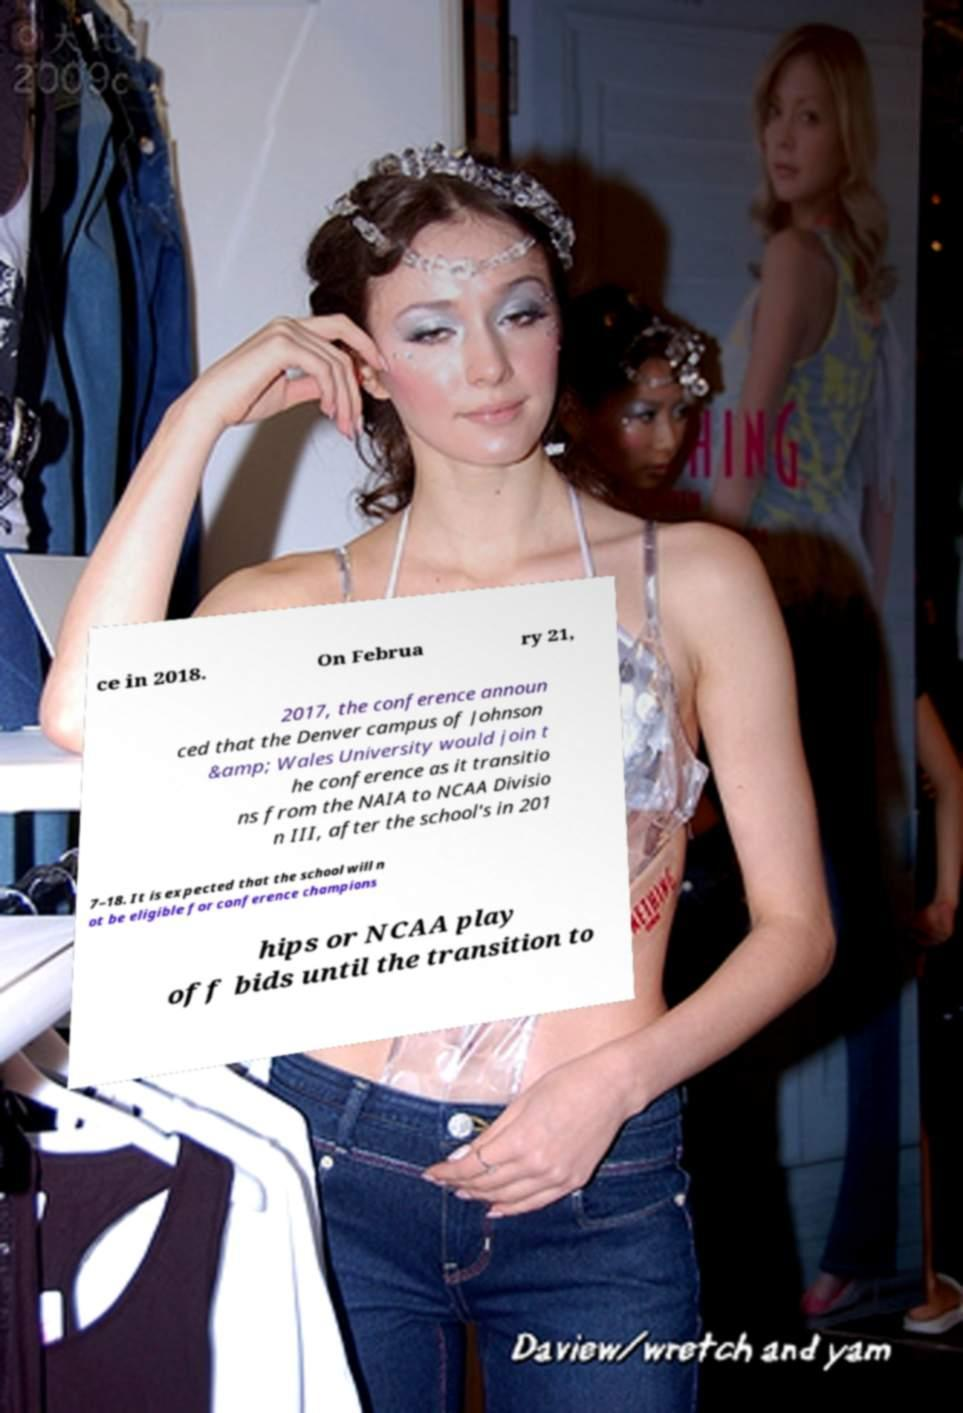Please identify and transcribe the text found in this image. ce in 2018. On Februa ry 21, 2017, the conference announ ced that the Denver campus of Johnson &amp; Wales University would join t he conference as it transitio ns from the NAIA to NCAA Divisio n III, after the school's in 201 7–18. It is expected that the school will n ot be eligible for conference champions hips or NCAA play off bids until the transition to 